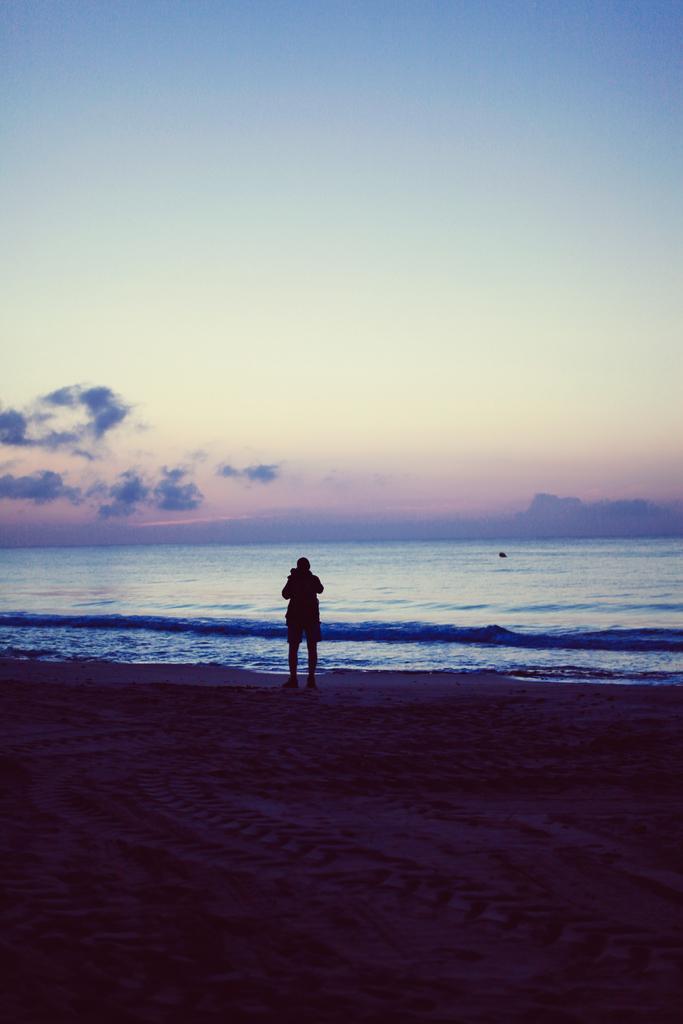Can you describe this image briefly? In this image we can see a person standing on the ground. In the background, we can see the water and the sky. 